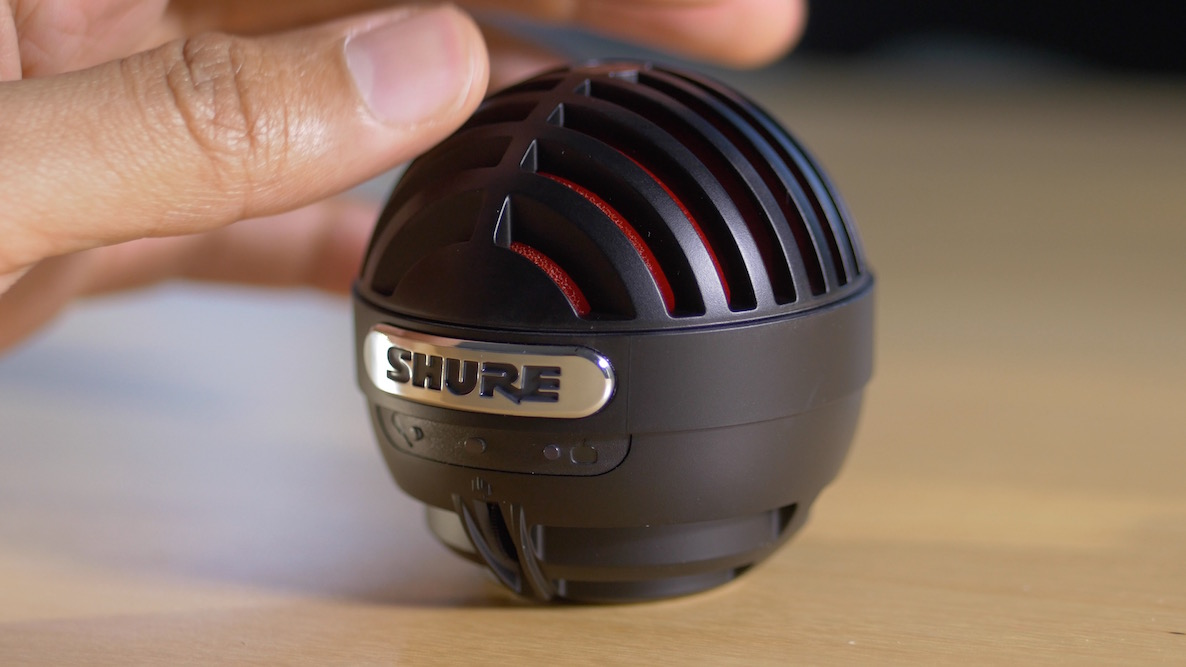What is the purpose of the red foam visible under the mesh grille of the microphone? The red foam visible beneath the mesh grille of the Shure microphone primarily functions as a pop filter. It mitigates the harsh 'popping' sounds produced when pronouncing plosive consonants, like 'p' and 'b', which generate a burst of air pressure that can create an unwanted popping sound in recordings. This foam layer also helps in shielding the delicate internal components of the microphone from dust, moisture, and debris, such as saliva, which not only enhances audio quality but also promotes the longevity of the microphone. Such features are crucial for maintaining pristine sound clarity and protection in both studio and live environments. 